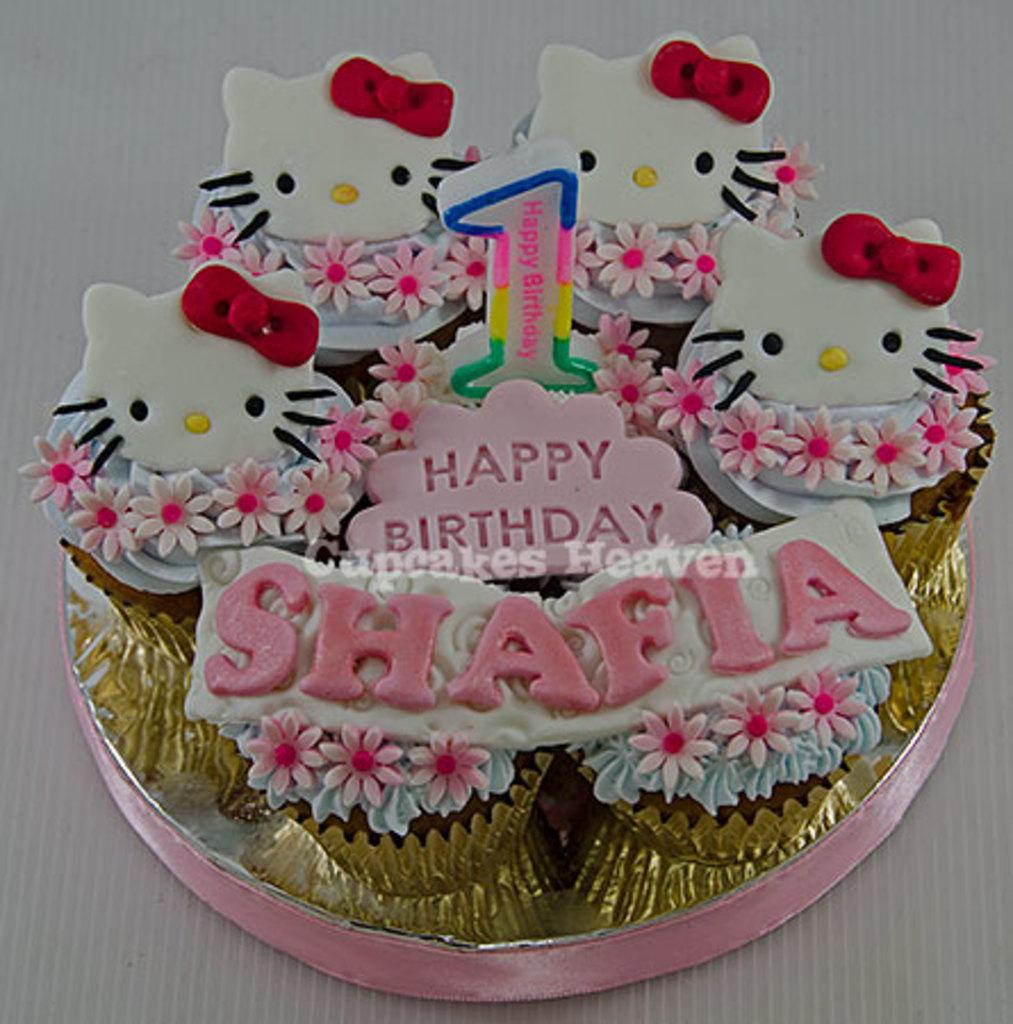What is the main subject of the image? The main subject of the image is a birthday cake. What is on top of the birthday cake? The birthday cake has a candle on top. What is the birthday cake placed on? The birthday cake is placed on an object, but the specific object is not mentioned in the facts. Can you describe any additional features of the image? There is a watermark at the center of the image. What type of coal is being used to fuel the candles on the birthday cake? There is no coal present in the image, and the candles are not fueled by coal. Is there a board game being played on the object that the birthday cake is placed on? There is no information about a board game or any other activity taking place on the object that the birthday cake is placed on. 